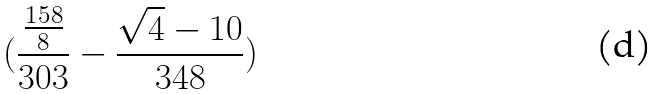<formula> <loc_0><loc_0><loc_500><loc_500>( \frac { \frac { 1 5 8 } { 8 } } { 3 0 3 } - \frac { \sqrt { 4 } - 1 0 } { 3 4 8 } )</formula> 